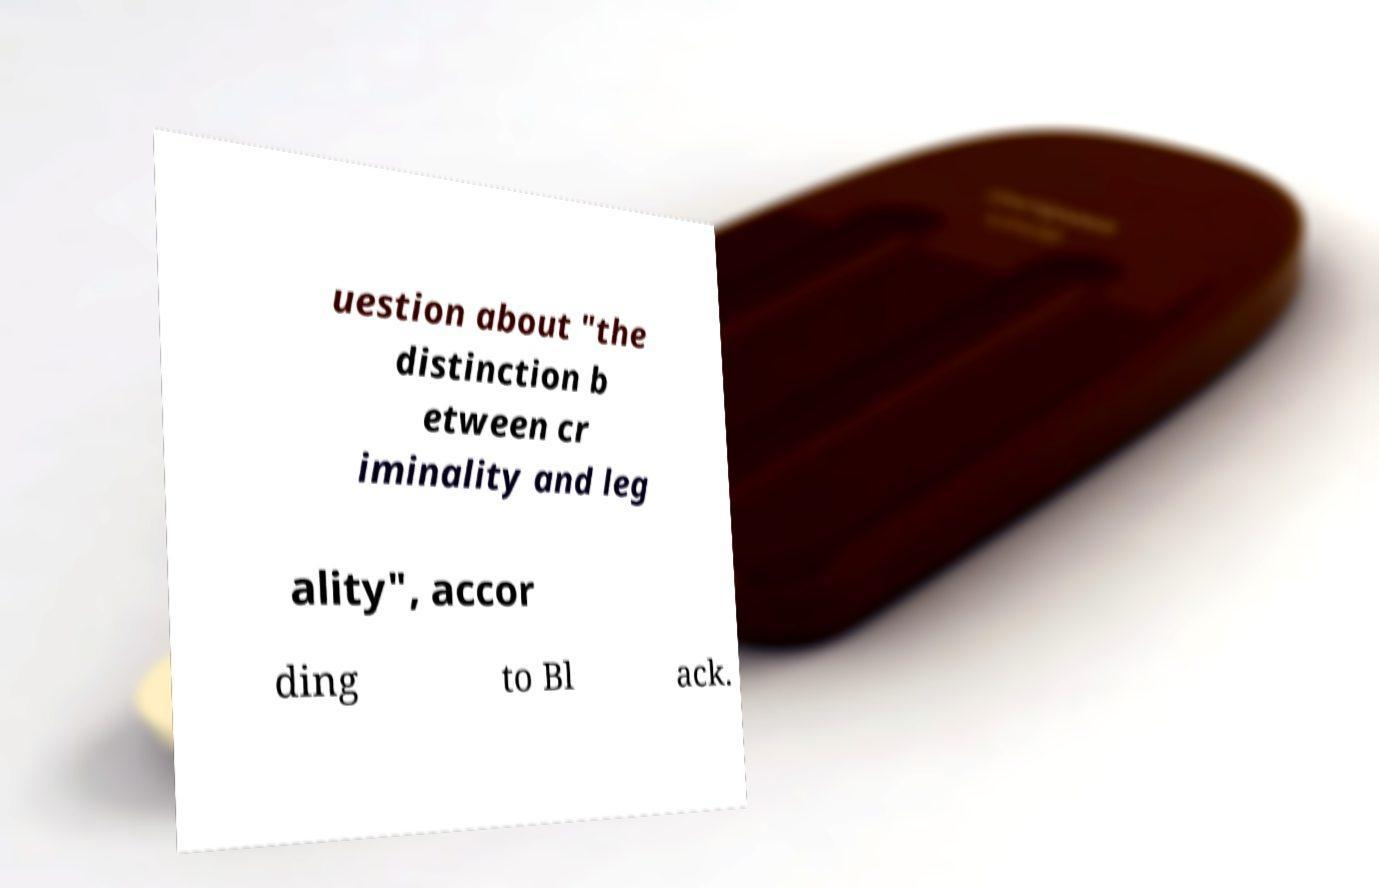There's text embedded in this image that I need extracted. Can you transcribe it verbatim? uestion about "the distinction b etween cr iminality and leg ality", accor ding to Bl ack. 